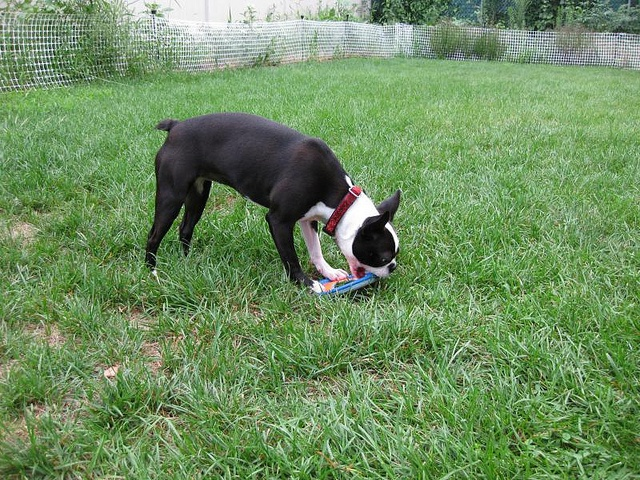Describe the objects in this image and their specific colors. I can see dog in lightgray, black, gray, and white tones and frisbee in lightgray, white, gray, and lightblue tones in this image. 